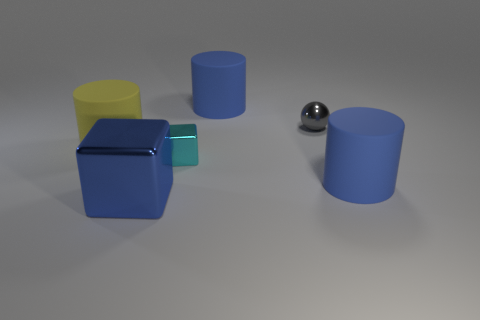Subtract all yellow blocks. Subtract all gray spheres. How many blocks are left? 2 Add 2 yellow cylinders. How many objects exist? 8 Subtract all cubes. How many objects are left? 4 Add 4 cylinders. How many cylinders are left? 7 Add 5 yellow rubber things. How many yellow rubber things exist? 6 Subtract 0 cyan cylinders. How many objects are left? 6 Subtract all big blue shiny cubes. Subtract all yellow cylinders. How many objects are left? 4 